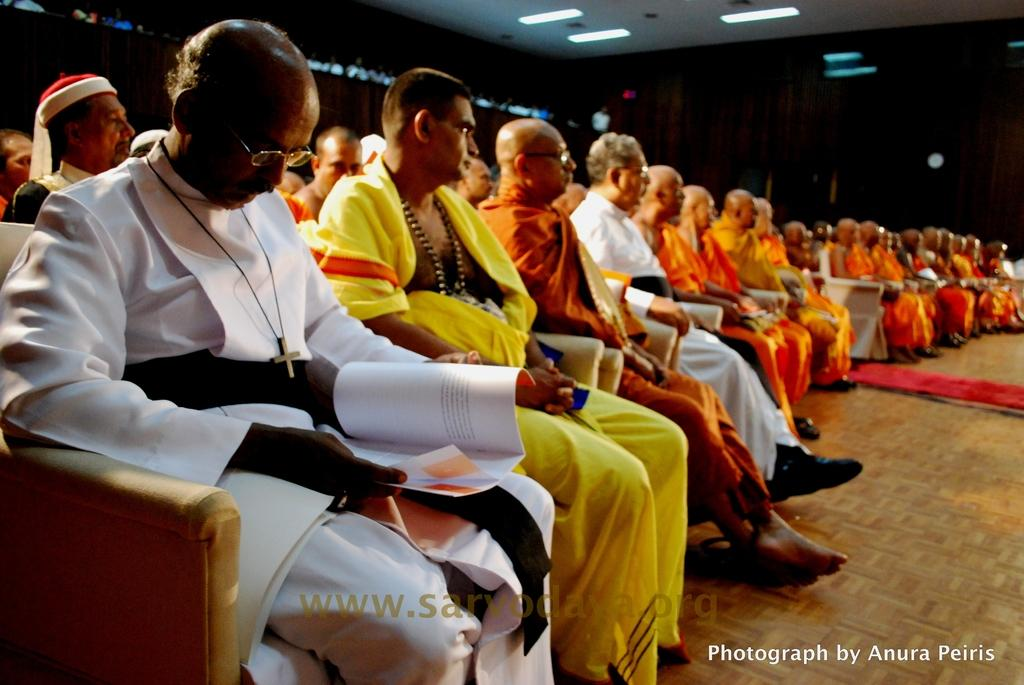What is the main subject of the image? The main subject of the image is a group of people. What are the people doing in the image? The people are sitting on sofa chairs. What direction are the people looking in the image? The people are looking at the right side. What type of lighting is present in the image? There are ceiling lights visible in the image. What type of grape is being used for writing on the arm of the person in the image? There is no grape or writing present in the image. The people are sitting on sofa chairs and looking at the right side, with no mention of grapes or writing on anyone's arm. 